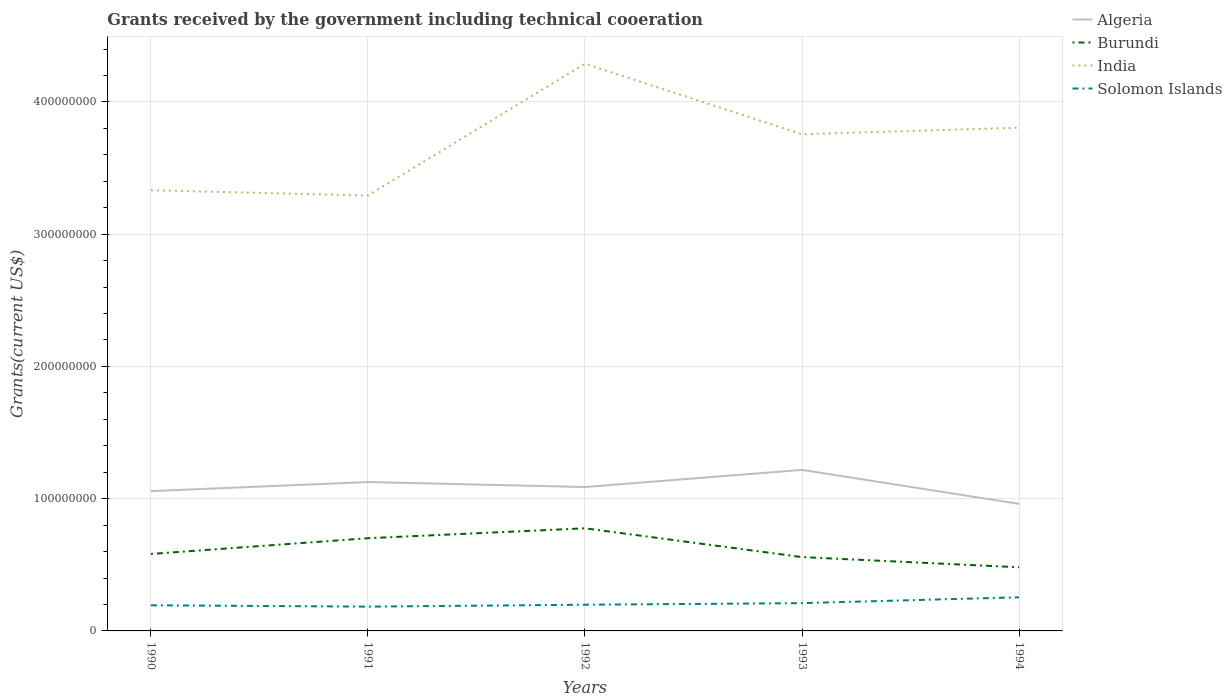How many different coloured lines are there?
Your answer should be very brief. 4. Does the line corresponding to Burundi intersect with the line corresponding to India?
Offer a terse response. No. Across all years, what is the maximum total grants received by the government in Burundi?
Offer a terse response. 4.81e+07. What is the total total grants received by the government in Solomon Islands in the graph?
Keep it short and to the point. -4.43e+06. What is the difference between the highest and the second highest total grants received by the government in Burundi?
Make the answer very short. 2.95e+07. What is the difference between the highest and the lowest total grants received by the government in Burundi?
Make the answer very short. 2. How many years are there in the graph?
Your answer should be compact. 5. Does the graph contain grids?
Your response must be concise. Yes. How are the legend labels stacked?
Provide a short and direct response. Vertical. What is the title of the graph?
Ensure brevity in your answer.  Grants received by the government including technical cooeration. Does "Sierra Leone" appear as one of the legend labels in the graph?
Provide a succinct answer. No. What is the label or title of the X-axis?
Provide a succinct answer. Years. What is the label or title of the Y-axis?
Offer a terse response. Grants(current US$). What is the Grants(current US$) of Algeria in 1990?
Offer a very short reply. 1.06e+08. What is the Grants(current US$) of Burundi in 1990?
Ensure brevity in your answer.  5.82e+07. What is the Grants(current US$) of India in 1990?
Keep it short and to the point. 3.33e+08. What is the Grants(current US$) in Solomon Islands in 1990?
Offer a terse response. 1.94e+07. What is the Grants(current US$) of Algeria in 1991?
Ensure brevity in your answer.  1.13e+08. What is the Grants(current US$) of Burundi in 1991?
Ensure brevity in your answer.  7.01e+07. What is the Grants(current US$) in India in 1991?
Offer a terse response. 3.29e+08. What is the Grants(current US$) in Solomon Islands in 1991?
Provide a succinct answer. 1.84e+07. What is the Grants(current US$) of Algeria in 1992?
Your response must be concise. 1.09e+08. What is the Grants(current US$) in Burundi in 1992?
Your response must be concise. 7.76e+07. What is the Grants(current US$) in India in 1992?
Ensure brevity in your answer.  4.29e+08. What is the Grants(current US$) in Solomon Islands in 1992?
Make the answer very short. 1.98e+07. What is the Grants(current US$) in Algeria in 1993?
Ensure brevity in your answer.  1.22e+08. What is the Grants(current US$) of Burundi in 1993?
Your response must be concise. 5.58e+07. What is the Grants(current US$) of India in 1993?
Keep it short and to the point. 3.76e+08. What is the Grants(current US$) in Solomon Islands in 1993?
Provide a short and direct response. 2.10e+07. What is the Grants(current US$) of Algeria in 1994?
Make the answer very short. 9.61e+07. What is the Grants(current US$) of Burundi in 1994?
Give a very brief answer. 4.81e+07. What is the Grants(current US$) in India in 1994?
Your answer should be very brief. 3.81e+08. What is the Grants(current US$) in Solomon Islands in 1994?
Your answer should be very brief. 2.54e+07. Across all years, what is the maximum Grants(current US$) of Algeria?
Keep it short and to the point. 1.22e+08. Across all years, what is the maximum Grants(current US$) of Burundi?
Make the answer very short. 7.76e+07. Across all years, what is the maximum Grants(current US$) of India?
Your response must be concise. 4.29e+08. Across all years, what is the maximum Grants(current US$) of Solomon Islands?
Your answer should be very brief. 2.54e+07. Across all years, what is the minimum Grants(current US$) of Algeria?
Provide a short and direct response. 9.61e+07. Across all years, what is the minimum Grants(current US$) in Burundi?
Offer a terse response. 4.81e+07. Across all years, what is the minimum Grants(current US$) of India?
Provide a short and direct response. 3.29e+08. Across all years, what is the minimum Grants(current US$) in Solomon Islands?
Your answer should be very brief. 1.84e+07. What is the total Grants(current US$) of Algeria in the graph?
Your answer should be very brief. 5.45e+08. What is the total Grants(current US$) of Burundi in the graph?
Your response must be concise. 3.10e+08. What is the total Grants(current US$) in India in the graph?
Offer a very short reply. 1.85e+09. What is the total Grants(current US$) of Solomon Islands in the graph?
Keep it short and to the point. 1.04e+08. What is the difference between the Grants(current US$) in Algeria in 1990 and that in 1991?
Give a very brief answer. -6.87e+06. What is the difference between the Grants(current US$) of Burundi in 1990 and that in 1991?
Keep it short and to the point. -1.19e+07. What is the difference between the Grants(current US$) in India in 1990 and that in 1991?
Your answer should be compact. 3.99e+06. What is the difference between the Grants(current US$) in Solomon Islands in 1990 and that in 1991?
Your answer should be very brief. 1.01e+06. What is the difference between the Grants(current US$) of Algeria in 1990 and that in 1992?
Your response must be concise. -3.10e+06. What is the difference between the Grants(current US$) of Burundi in 1990 and that in 1992?
Your response must be concise. -1.94e+07. What is the difference between the Grants(current US$) in India in 1990 and that in 1992?
Give a very brief answer. -9.57e+07. What is the difference between the Grants(current US$) of Solomon Islands in 1990 and that in 1992?
Provide a succinct answer. -4.20e+05. What is the difference between the Grants(current US$) in Algeria in 1990 and that in 1993?
Your answer should be compact. -1.61e+07. What is the difference between the Grants(current US$) of Burundi in 1990 and that in 1993?
Provide a short and direct response. 2.36e+06. What is the difference between the Grants(current US$) of India in 1990 and that in 1993?
Provide a short and direct response. -4.23e+07. What is the difference between the Grants(current US$) in Solomon Islands in 1990 and that in 1993?
Your response must be concise. -1.63e+06. What is the difference between the Grants(current US$) in Algeria in 1990 and that in 1994?
Your answer should be compact. 9.63e+06. What is the difference between the Grants(current US$) of Burundi in 1990 and that in 1994?
Your answer should be compact. 1.01e+07. What is the difference between the Grants(current US$) of India in 1990 and that in 1994?
Provide a short and direct response. -4.73e+07. What is the difference between the Grants(current US$) of Solomon Islands in 1990 and that in 1994?
Your answer should be very brief. -6.06e+06. What is the difference between the Grants(current US$) in Algeria in 1991 and that in 1992?
Make the answer very short. 3.77e+06. What is the difference between the Grants(current US$) in Burundi in 1991 and that in 1992?
Your answer should be compact. -7.50e+06. What is the difference between the Grants(current US$) of India in 1991 and that in 1992?
Provide a succinct answer. -9.97e+07. What is the difference between the Grants(current US$) of Solomon Islands in 1991 and that in 1992?
Your answer should be compact. -1.43e+06. What is the difference between the Grants(current US$) of Algeria in 1991 and that in 1993?
Provide a short and direct response. -9.19e+06. What is the difference between the Grants(current US$) of Burundi in 1991 and that in 1993?
Offer a terse response. 1.43e+07. What is the difference between the Grants(current US$) in India in 1991 and that in 1993?
Ensure brevity in your answer.  -4.63e+07. What is the difference between the Grants(current US$) in Solomon Islands in 1991 and that in 1993?
Offer a very short reply. -2.64e+06. What is the difference between the Grants(current US$) in Algeria in 1991 and that in 1994?
Keep it short and to the point. 1.65e+07. What is the difference between the Grants(current US$) in Burundi in 1991 and that in 1994?
Keep it short and to the point. 2.20e+07. What is the difference between the Grants(current US$) of India in 1991 and that in 1994?
Keep it short and to the point. -5.13e+07. What is the difference between the Grants(current US$) in Solomon Islands in 1991 and that in 1994?
Your answer should be very brief. -7.07e+06. What is the difference between the Grants(current US$) in Algeria in 1992 and that in 1993?
Keep it short and to the point. -1.30e+07. What is the difference between the Grants(current US$) of Burundi in 1992 and that in 1993?
Ensure brevity in your answer.  2.18e+07. What is the difference between the Grants(current US$) of India in 1992 and that in 1993?
Ensure brevity in your answer.  5.33e+07. What is the difference between the Grants(current US$) of Solomon Islands in 1992 and that in 1993?
Offer a very short reply. -1.21e+06. What is the difference between the Grants(current US$) of Algeria in 1992 and that in 1994?
Your response must be concise. 1.27e+07. What is the difference between the Grants(current US$) in Burundi in 1992 and that in 1994?
Give a very brief answer. 2.95e+07. What is the difference between the Grants(current US$) of India in 1992 and that in 1994?
Your answer should be compact. 4.84e+07. What is the difference between the Grants(current US$) of Solomon Islands in 1992 and that in 1994?
Offer a terse response. -5.64e+06. What is the difference between the Grants(current US$) of Algeria in 1993 and that in 1994?
Give a very brief answer. 2.57e+07. What is the difference between the Grants(current US$) in Burundi in 1993 and that in 1994?
Your answer should be very brief. 7.72e+06. What is the difference between the Grants(current US$) of India in 1993 and that in 1994?
Keep it short and to the point. -4.98e+06. What is the difference between the Grants(current US$) in Solomon Islands in 1993 and that in 1994?
Provide a short and direct response. -4.43e+06. What is the difference between the Grants(current US$) in Algeria in 1990 and the Grants(current US$) in Burundi in 1991?
Make the answer very short. 3.56e+07. What is the difference between the Grants(current US$) of Algeria in 1990 and the Grants(current US$) of India in 1991?
Your answer should be compact. -2.24e+08. What is the difference between the Grants(current US$) of Algeria in 1990 and the Grants(current US$) of Solomon Islands in 1991?
Keep it short and to the point. 8.73e+07. What is the difference between the Grants(current US$) in Burundi in 1990 and the Grants(current US$) in India in 1991?
Offer a terse response. -2.71e+08. What is the difference between the Grants(current US$) of Burundi in 1990 and the Grants(current US$) of Solomon Islands in 1991?
Ensure brevity in your answer.  3.98e+07. What is the difference between the Grants(current US$) of India in 1990 and the Grants(current US$) of Solomon Islands in 1991?
Your answer should be very brief. 3.15e+08. What is the difference between the Grants(current US$) in Algeria in 1990 and the Grants(current US$) in Burundi in 1992?
Your answer should be very brief. 2.81e+07. What is the difference between the Grants(current US$) in Algeria in 1990 and the Grants(current US$) in India in 1992?
Ensure brevity in your answer.  -3.23e+08. What is the difference between the Grants(current US$) in Algeria in 1990 and the Grants(current US$) in Solomon Islands in 1992?
Give a very brief answer. 8.59e+07. What is the difference between the Grants(current US$) of Burundi in 1990 and the Grants(current US$) of India in 1992?
Keep it short and to the point. -3.71e+08. What is the difference between the Grants(current US$) of Burundi in 1990 and the Grants(current US$) of Solomon Islands in 1992?
Provide a short and direct response. 3.84e+07. What is the difference between the Grants(current US$) of India in 1990 and the Grants(current US$) of Solomon Islands in 1992?
Keep it short and to the point. 3.13e+08. What is the difference between the Grants(current US$) in Algeria in 1990 and the Grants(current US$) in Burundi in 1993?
Keep it short and to the point. 4.99e+07. What is the difference between the Grants(current US$) of Algeria in 1990 and the Grants(current US$) of India in 1993?
Offer a very short reply. -2.70e+08. What is the difference between the Grants(current US$) in Algeria in 1990 and the Grants(current US$) in Solomon Islands in 1993?
Ensure brevity in your answer.  8.47e+07. What is the difference between the Grants(current US$) in Burundi in 1990 and the Grants(current US$) in India in 1993?
Offer a very short reply. -3.17e+08. What is the difference between the Grants(current US$) in Burundi in 1990 and the Grants(current US$) in Solomon Islands in 1993?
Your response must be concise. 3.72e+07. What is the difference between the Grants(current US$) of India in 1990 and the Grants(current US$) of Solomon Islands in 1993?
Provide a succinct answer. 3.12e+08. What is the difference between the Grants(current US$) of Algeria in 1990 and the Grants(current US$) of Burundi in 1994?
Give a very brief answer. 5.76e+07. What is the difference between the Grants(current US$) of Algeria in 1990 and the Grants(current US$) of India in 1994?
Provide a succinct answer. -2.75e+08. What is the difference between the Grants(current US$) of Algeria in 1990 and the Grants(current US$) of Solomon Islands in 1994?
Your answer should be very brief. 8.03e+07. What is the difference between the Grants(current US$) in Burundi in 1990 and the Grants(current US$) in India in 1994?
Provide a short and direct response. -3.22e+08. What is the difference between the Grants(current US$) of Burundi in 1990 and the Grants(current US$) of Solomon Islands in 1994?
Your answer should be compact. 3.28e+07. What is the difference between the Grants(current US$) of India in 1990 and the Grants(current US$) of Solomon Islands in 1994?
Offer a terse response. 3.08e+08. What is the difference between the Grants(current US$) of Algeria in 1991 and the Grants(current US$) of Burundi in 1992?
Provide a short and direct response. 3.50e+07. What is the difference between the Grants(current US$) of Algeria in 1991 and the Grants(current US$) of India in 1992?
Provide a succinct answer. -3.16e+08. What is the difference between the Grants(current US$) of Algeria in 1991 and the Grants(current US$) of Solomon Islands in 1992?
Ensure brevity in your answer.  9.28e+07. What is the difference between the Grants(current US$) in Burundi in 1991 and the Grants(current US$) in India in 1992?
Ensure brevity in your answer.  -3.59e+08. What is the difference between the Grants(current US$) of Burundi in 1991 and the Grants(current US$) of Solomon Islands in 1992?
Give a very brief answer. 5.03e+07. What is the difference between the Grants(current US$) in India in 1991 and the Grants(current US$) in Solomon Islands in 1992?
Give a very brief answer. 3.09e+08. What is the difference between the Grants(current US$) of Algeria in 1991 and the Grants(current US$) of Burundi in 1993?
Your answer should be very brief. 5.67e+07. What is the difference between the Grants(current US$) in Algeria in 1991 and the Grants(current US$) in India in 1993?
Your answer should be compact. -2.63e+08. What is the difference between the Grants(current US$) of Algeria in 1991 and the Grants(current US$) of Solomon Islands in 1993?
Give a very brief answer. 9.16e+07. What is the difference between the Grants(current US$) in Burundi in 1991 and the Grants(current US$) in India in 1993?
Ensure brevity in your answer.  -3.05e+08. What is the difference between the Grants(current US$) of Burundi in 1991 and the Grants(current US$) of Solomon Islands in 1993?
Provide a short and direct response. 4.91e+07. What is the difference between the Grants(current US$) of India in 1991 and the Grants(current US$) of Solomon Islands in 1993?
Provide a succinct answer. 3.08e+08. What is the difference between the Grants(current US$) of Algeria in 1991 and the Grants(current US$) of Burundi in 1994?
Make the answer very short. 6.45e+07. What is the difference between the Grants(current US$) in Algeria in 1991 and the Grants(current US$) in India in 1994?
Your response must be concise. -2.68e+08. What is the difference between the Grants(current US$) of Algeria in 1991 and the Grants(current US$) of Solomon Islands in 1994?
Offer a very short reply. 8.71e+07. What is the difference between the Grants(current US$) of Burundi in 1991 and the Grants(current US$) of India in 1994?
Offer a terse response. -3.10e+08. What is the difference between the Grants(current US$) in Burundi in 1991 and the Grants(current US$) in Solomon Islands in 1994?
Keep it short and to the point. 4.46e+07. What is the difference between the Grants(current US$) in India in 1991 and the Grants(current US$) in Solomon Islands in 1994?
Make the answer very short. 3.04e+08. What is the difference between the Grants(current US$) of Algeria in 1992 and the Grants(current US$) of Burundi in 1993?
Offer a very short reply. 5.30e+07. What is the difference between the Grants(current US$) of Algeria in 1992 and the Grants(current US$) of India in 1993?
Provide a short and direct response. -2.67e+08. What is the difference between the Grants(current US$) of Algeria in 1992 and the Grants(current US$) of Solomon Islands in 1993?
Give a very brief answer. 8.78e+07. What is the difference between the Grants(current US$) of Burundi in 1992 and the Grants(current US$) of India in 1993?
Make the answer very short. -2.98e+08. What is the difference between the Grants(current US$) of Burundi in 1992 and the Grants(current US$) of Solomon Islands in 1993?
Your answer should be compact. 5.66e+07. What is the difference between the Grants(current US$) of India in 1992 and the Grants(current US$) of Solomon Islands in 1993?
Your answer should be compact. 4.08e+08. What is the difference between the Grants(current US$) of Algeria in 1992 and the Grants(current US$) of Burundi in 1994?
Give a very brief answer. 6.07e+07. What is the difference between the Grants(current US$) of Algeria in 1992 and the Grants(current US$) of India in 1994?
Offer a very short reply. -2.72e+08. What is the difference between the Grants(current US$) in Algeria in 1992 and the Grants(current US$) in Solomon Islands in 1994?
Offer a very short reply. 8.34e+07. What is the difference between the Grants(current US$) in Burundi in 1992 and the Grants(current US$) in India in 1994?
Provide a short and direct response. -3.03e+08. What is the difference between the Grants(current US$) in Burundi in 1992 and the Grants(current US$) in Solomon Islands in 1994?
Give a very brief answer. 5.22e+07. What is the difference between the Grants(current US$) of India in 1992 and the Grants(current US$) of Solomon Islands in 1994?
Provide a short and direct response. 4.03e+08. What is the difference between the Grants(current US$) in Algeria in 1993 and the Grants(current US$) in Burundi in 1994?
Offer a very short reply. 7.36e+07. What is the difference between the Grants(current US$) of Algeria in 1993 and the Grants(current US$) of India in 1994?
Make the answer very short. -2.59e+08. What is the difference between the Grants(current US$) in Algeria in 1993 and the Grants(current US$) in Solomon Islands in 1994?
Provide a short and direct response. 9.63e+07. What is the difference between the Grants(current US$) in Burundi in 1993 and the Grants(current US$) in India in 1994?
Ensure brevity in your answer.  -3.25e+08. What is the difference between the Grants(current US$) of Burundi in 1993 and the Grants(current US$) of Solomon Islands in 1994?
Keep it short and to the point. 3.04e+07. What is the difference between the Grants(current US$) of India in 1993 and the Grants(current US$) of Solomon Islands in 1994?
Ensure brevity in your answer.  3.50e+08. What is the average Grants(current US$) of Algeria per year?
Make the answer very short. 1.09e+08. What is the average Grants(current US$) of Burundi per year?
Give a very brief answer. 6.20e+07. What is the average Grants(current US$) of India per year?
Your response must be concise. 3.69e+08. What is the average Grants(current US$) of Solomon Islands per year?
Your response must be concise. 2.08e+07. In the year 1990, what is the difference between the Grants(current US$) of Algeria and Grants(current US$) of Burundi?
Your response must be concise. 4.75e+07. In the year 1990, what is the difference between the Grants(current US$) in Algeria and Grants(current US$) in India?
Offer a terse response. -2.28e+08. In the year 1990, what is the difference between the Grants(current US$) of Algeria and Grants(current US$) of Solomon Islands?
Offer a terse response. 8.63e+07. In the year 1990, what is the difference between the Grants(current US$) in Burundi and Grants(current US$) in India?
Your answer should be compact. -2.75e+08. In the year 1990, what is the difference between the Grants(current US$) in Burundi and Grants(current US$) in Solomon Islands?
Provide a short and direct response. 3.88e+07. In the year 1990, what is the difference between the Grants(current US$) of India and Grants(current US$) of Solomon Islands?
Provide a succinct answer. 3.14e+08. In the year 1991, what is the difference between the Grants(current US$) of Algeria and Grants(current US$) of Burundi?
Ensure brevity in your answer.  4.25e+07. In the year 1991, what is the difference between the Grants(current US$) in Algeria and Grants(current US$) in India?
Keep it short and to the point. -2.17e+08. In the year 1991, what is the difference between the Grants(current US$) in Algeria and Grants(current US$) in Solomon Islands?
Make the answer very short. 9.42e+07. In the year 1991, what is the difference between the Grants(current US$) in Burundi and Grants(current US$) in India?
Provide a short and direct response. -2.59e+08. In the year 1991, what is the difference between the Grants(current US$) of Burundi and Grants(current US$) of Solomon Islands?
Provide a succinct answer. 5.17e+07. In the year 1991, what is the difference between the Grants(current US$) in India and Grants(current US$) in Solomon Islands?
Your answer should be very brief. 3.11e+08. In the year 1992, what is the difference between the Grants(current US$) in Algeria and Grants(current US$) in Burundi?
Your answer should be compact. 3.12e+07. In the year 1992, what is the difference between the Grants(current US$) of Algeria and Grants(current US$) of India?
Offer a terse response. -3.20e+08. In the year 1992, what is the difference between the Grants(current US$) of Algeria and Grants(current US$) of Solomon Islands?
Provide a succinct answer. 8.90e+07. In the year 1992, what is the difference between the Grants(current US$) of Burundi and Grants(current US$) of India?
Offer a very short reply. -3.51e+08. In the year 1992, what is the difference between the Grants(current US$) in Burundi and Grants(current US$) in Solomon Islands?
Provide a short and direct response. 5.78e+07. In the year 1992, what is the difference between the Grants(current US$) in India and Grants(current US$) in Solomon Islands?
Provide a succinct answer. 4.09e+08. In the year 1993, what is the difference between the Grants(current US$) of Algeria and Grants(current US$) of Burundi?
Make the answer very short. 6.59e+07. In the year 1993, what is the difference between the Grants(current US$) of Algeria and Grants(current US$) of India?
Give a very brief answer. -2.54e+08. In the year 1993, what is the difference between the Grants(current US$) in Algeria and Grants(current US$) in Solomon Islands?
Provide a succinct answer. 1.01e+08. In the year 1993, what is the difference between the Grants(current US$) of Burundi and Grants(current US$) of India?
Your answer should be compact. -3.20e+08. In the year 1993, what is the difference between the Grants(current US$) in Burundi and Grants(current US$) in Solomon Islands?
Provide a succinct answer. 3.48e+07. In the year 1993, what is the difference between the Grants(current US$) of India and Grants(current US$) of Solomon Islands?
Make the answer very short. 3.55e+08. In the year 1994, what is the difference between the Grants(current US$) of Algeria and Grants(current US$) of Burundi?
Offer a very short reply. 4.80e+07. In the year 1994, what is the difference between the Grants(current US$) of Algeria and Grants(current US$) of India?
Give a very brief answer. -2.84e+08. In the year 1994, what is the difference between the Grants(current US$) in Algeria and Grants(current US$) in Solomon Islands?
Provide a short and direct response. 7.06e+07. In the year 1994, what is the difference between the Grants(current US$) of Burundi and Grants(current US$) of India?
Keep it short and to the point. -3.32e+08. In the year 1994, what is the difference between the Grants(current US$) of Burundi and Grants(current US$) of Solomon Islands?
Provide a succinct answer. 2.27e+07. In the year 1994, what is the difference between the Grants(current US$) in India and Grants(current US$) in Solomon Islands?
Offer a very short reply. 3.55e+08. What is the ratio of the Grants(current US$) in Algeria in 1990 to that in 1991?
Your answer should be very brief. 0.94. What is the ratio of the Grants(current US$) of Burundi in 1990 to that in 1991?
Ensure brevity in your answer.  0.83. What is the ratio of the Grants(current US$) in India in 1990 to that in 1991?
Provide a succinct answer. 1.01. What is the ratio of the Grants(current US$) of Solomon Islands in 1990 to that in 1991?
Provide a succinct answer. 1.05. What is the ratio of the Grants(current US$) of Algeria in 1990 to that in 1992?
Provide a succinct answer. 0.97. What is the ratio of the Grants(current US$) of India in 1990 to that in 1992?
Ensure brevity in your answer.  0.78. What is the ratio of the Grants(current US$) in Solomon Islands in 1990 to that in 1992?
Give a very brief answer. 0.98. What is the ratio of the Grants(current US$) in Algeria in 1990 to that in 1993?
Give a very brief answer. 0.87. What is the ratio of the Grants(current US$) of Burundi in 1990 to that in 1993?
Keep it short and to the point. 1.04. What is the ratio of the Grants(current US$) in India in 1990 to that in 1993?
Offer a terse response. 0.89. What is the ratio of the Grants(current US$) in Solomon Islands in 1990 to that in 1993?
Make the answer very short. 0.92. What is the ratio of the Grants(current US$) of Algeria in 1990 to that in 1994?
Provide a succinct answer. 1.1. What is the ratio of the Grants(current US$) of Burundi in 1990 to that in 1994?
Offer a very short reply. 1.21. What is the ratio of the Grants(current US$) in India in 1990 to that in 1994?
Ensure brevity in your answer.  0.88. What is the ratio of the Grants(current US$) in Solomon Islands in 1990 to that in 1994?
Offer a terse response. 0.76. What is the ratio of the Grants(current US$) of Algeria in 1991 to that in 1992?
Your response must be concise. 1.03. What is the ratio of the Grants(current US$) in Burundi in 1991 to that in 1992?
Ensure brevity in your answer.  0.9. What is the ratio of the Grants(current US$) in India in 1991 to that in 1992?
Your response must be concise. 0.77. What is the ratio of the Grants(current US$) of Solomon Islands in 1991 to that in 1992?
Provide a succinct answer. 0.93. What is the ratio of the Grants(current US$) in Algeria in 1991 to that in 1993?
Provide a succinct answer. 0.92. What is the ratio of the Grants(current US$) of Burundi in 1991 to that in 1993?
Your answer should be compact. 1.26. What is the ratio of the Grants(current US$) of India in 1991 to that in 1993?
Make the answer very short. 0.88. What is the ratio of the Grants(current US$) in Solomon Islands in 1991 to that in 1993?
Your response must be concise. 0.87. What is the ratio of the Grants(current US$) of Algeria in 1991 to that in 1994?
Ensure brevity in your answer.  1.17. What is the ratio of the Grants(current US$) of Burundi in 1991 to that in 1994?
Your response must be concise. 1.46. What is the ratio of the Grants(current US$) in India in 1991 to that in 1994?
Provide a succinct answer. 0.87. What is the ratio of the Grants(current US$) in Solomon Islands in 1991 to that in 1994?
Give a very brief answer. 0.72. What is the ratio of the Grants(current US$) in Algeria in 1992 to that in 1993?
Make the answer very short. 0.89. What is the ratio of the Grants(current US$) in Burundi in 1992 to that in 1993?
Your answer should be very brief. 1.39. What is the ratio of the Grants(current US$) in India in 1992 to that in 1993?
Offer a terse response. 1.14. What is the ratio of the Grants(current US$) in Solomon Islands in 1992 to that in 1993?
Provide a succinct answer. 0.94. What is the ratio of the Grants(current US$) in Algeria in 1992 to that in 1994?
Your answer should be very brief. 1.13. What is the ratio of the Grants(current US$) in Burundi in 1992 to that in 1994?
Ensure brevity in your answer.  1.61. What is the ratio of the Grants(current US$) of India in 1992 to that in 1994?
Keep it short and to the point. 1.13. What is the ratio of the Grants(current US$) of Solomon Islands in 1992 to that in 1994?
Ensure brevity in your answer.  0.78. What is the ratio of the Grants(current US$) of Algeria in 1993 to that in 1994?
Give a very brief answer. 1.27. What is the ratio of the Grants(current US$) in Burundi in 1993 to that in 1994?
Make the answer very short. 1.16. What is the ratio of the Grants(current US$) in India in 1993 to that in 1994?
Offer a terse response. 0.99. What is the ratio of the Grants(current US$) in Solomon Islands in 1993 to that in 1994?
Keep it short and to the point. 0.83. What is the difference between the highest and the second highest Grants(current US$) in Algeria?
Offer a terse response. 9.19e+06. What is the difference between the highest and the second highest Grants(current US$) of Burundi?
Provide a succinct answer. 7.50e+06. What is the difference between the highest and the second highest Grants(current US$) of India?
Your answer should be very brief. 4.84e+07. What is the difference between the highest and the second highest Grants(current US$) of Solomon Islands?
Give a very brief answer. 4.43e+06. What is the difference between the highest and the lowest Grants(current US$) in Algeria?
Keep it short and to the point. 2.57e+07. What is the difference between the highest and the lowest Grants(current US$) of Burundi?
Provide a short and direct response. 2.95e+07. What is the difference between the highest and the lowest Grants(current US$) of India?
Offer a terse response. 9.97e+07. What is the difference between the highest and the lowest Grants(current US$) in Solomon Islands?
Give a very brief answer. 7.07e+06. 